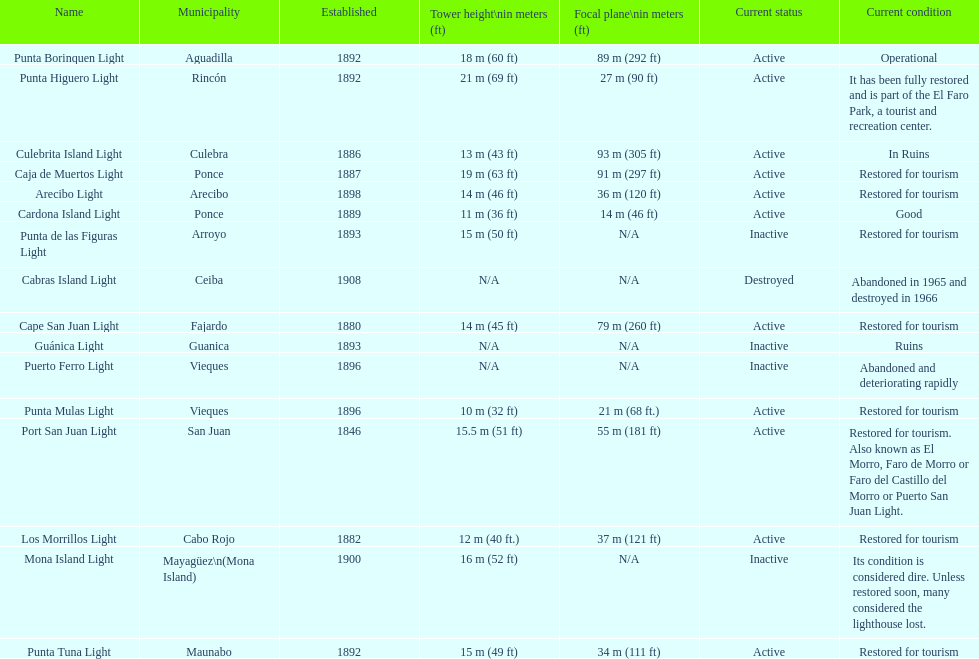Number of lighthouses that begin with the letter p 7. 